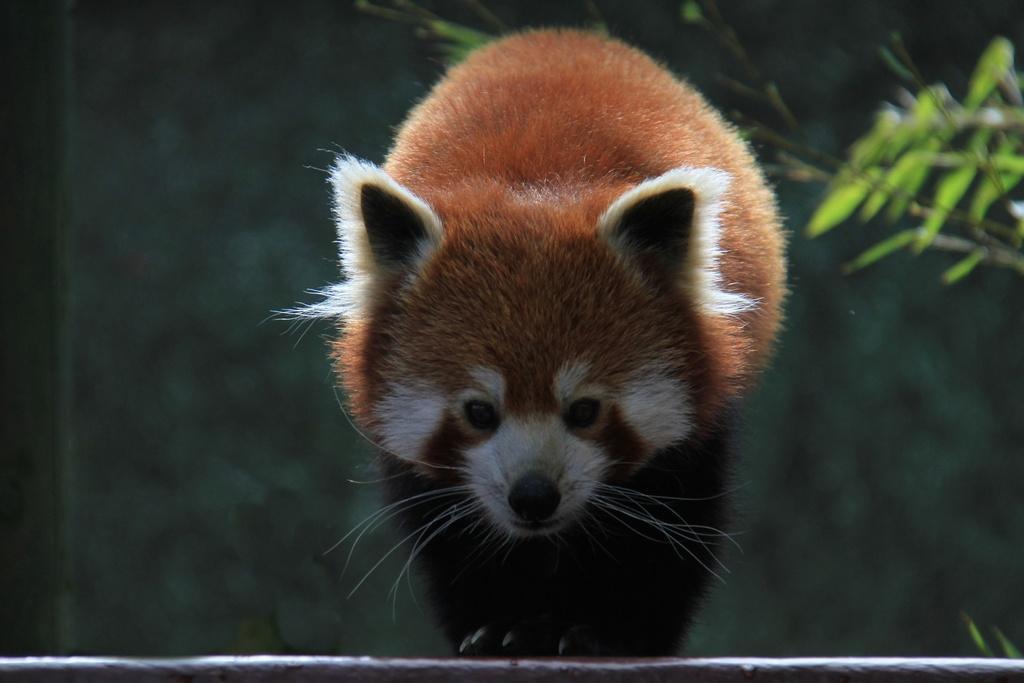In one or two sentences, can you explain what this image depicts? There is a picture of a red panda as we can see in the middle of this image. There are some leaves of a plant on the right side of this image. 